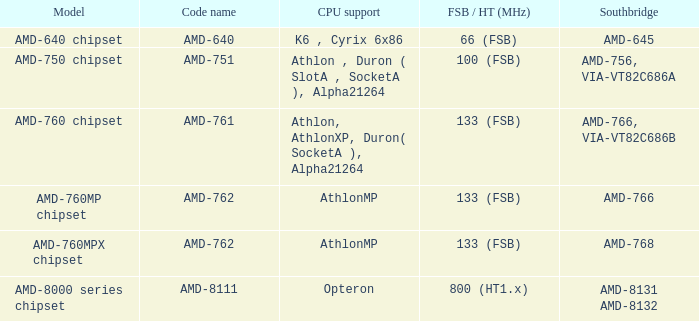What shows for Southbridge when the Model number is amd-640 chipset? AMD-645. 